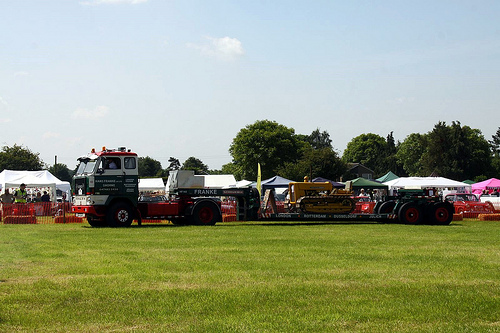<image>
Is there a truck on the grass? Yes. Looking at the image, I can see the truck is positioned on top of the grass, with the grass providing support. 